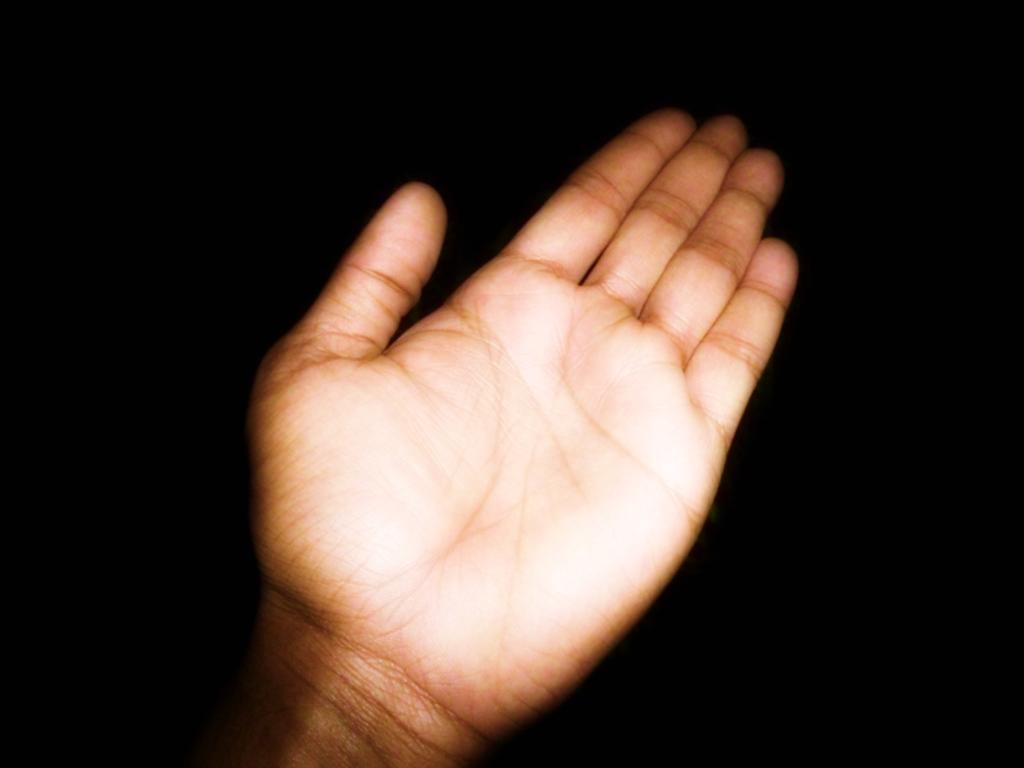Could you give a brief overview of what you see in this image? There is a hand of a person and the background is black in color. 